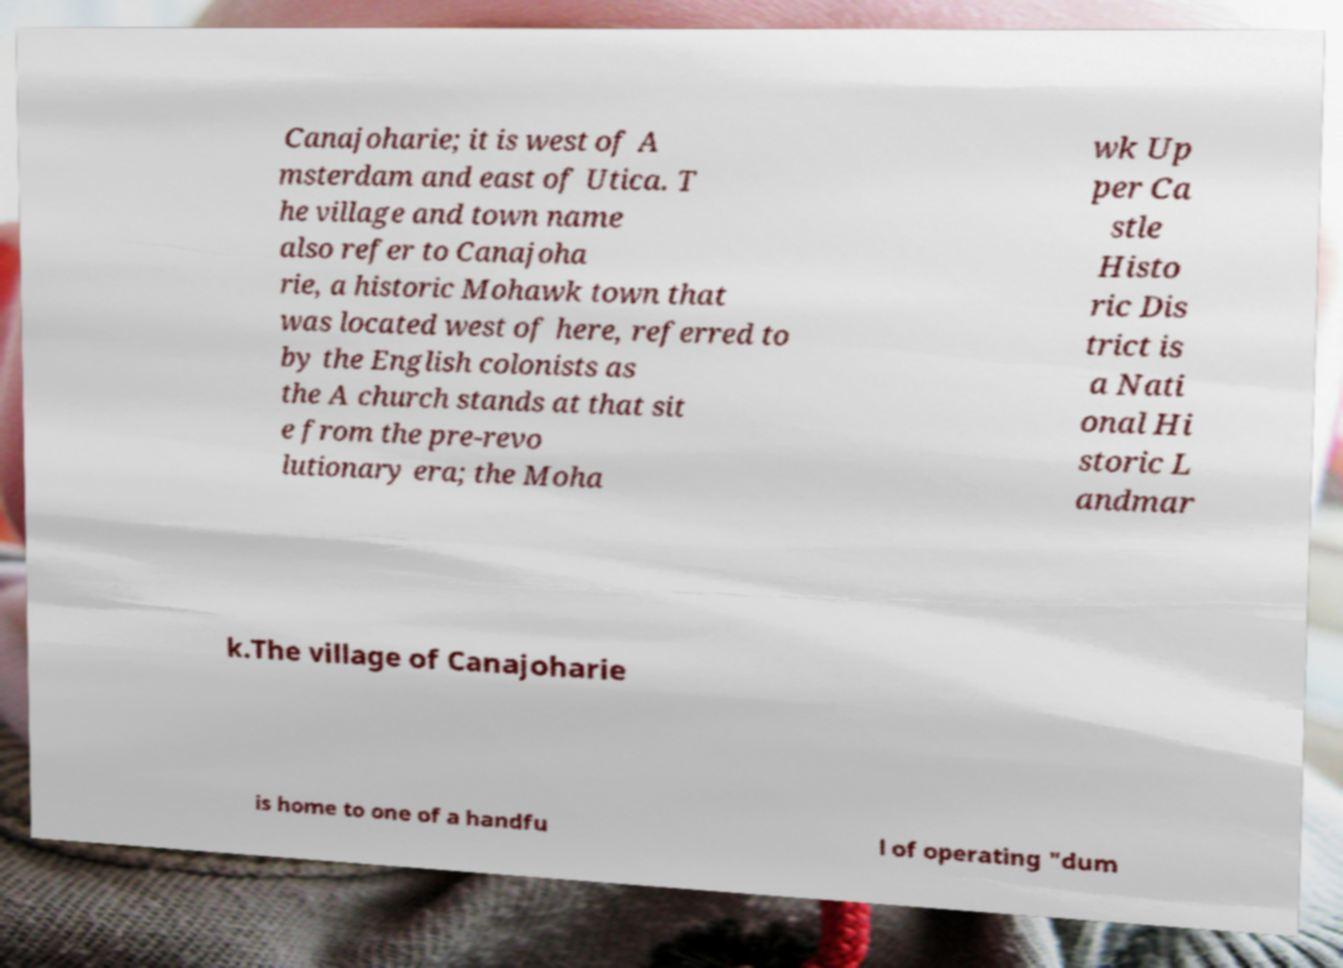Please identify and transcribe the text found in this image. Canajoharie; it is west of A msterdam and east of Utica. T he village and town name also refer to Canajoha rie, a historic Mohawk town that was located west of here, referred to by the English colonists as the A church stands at that sit e from the pre-revo lutionary era; the Moha wk Up per Ca stle Histo ric Dis trict is a Nati onal Hi storic L andmar k.The village of Canajoharie is home to one of a handfu l of operating "dum 